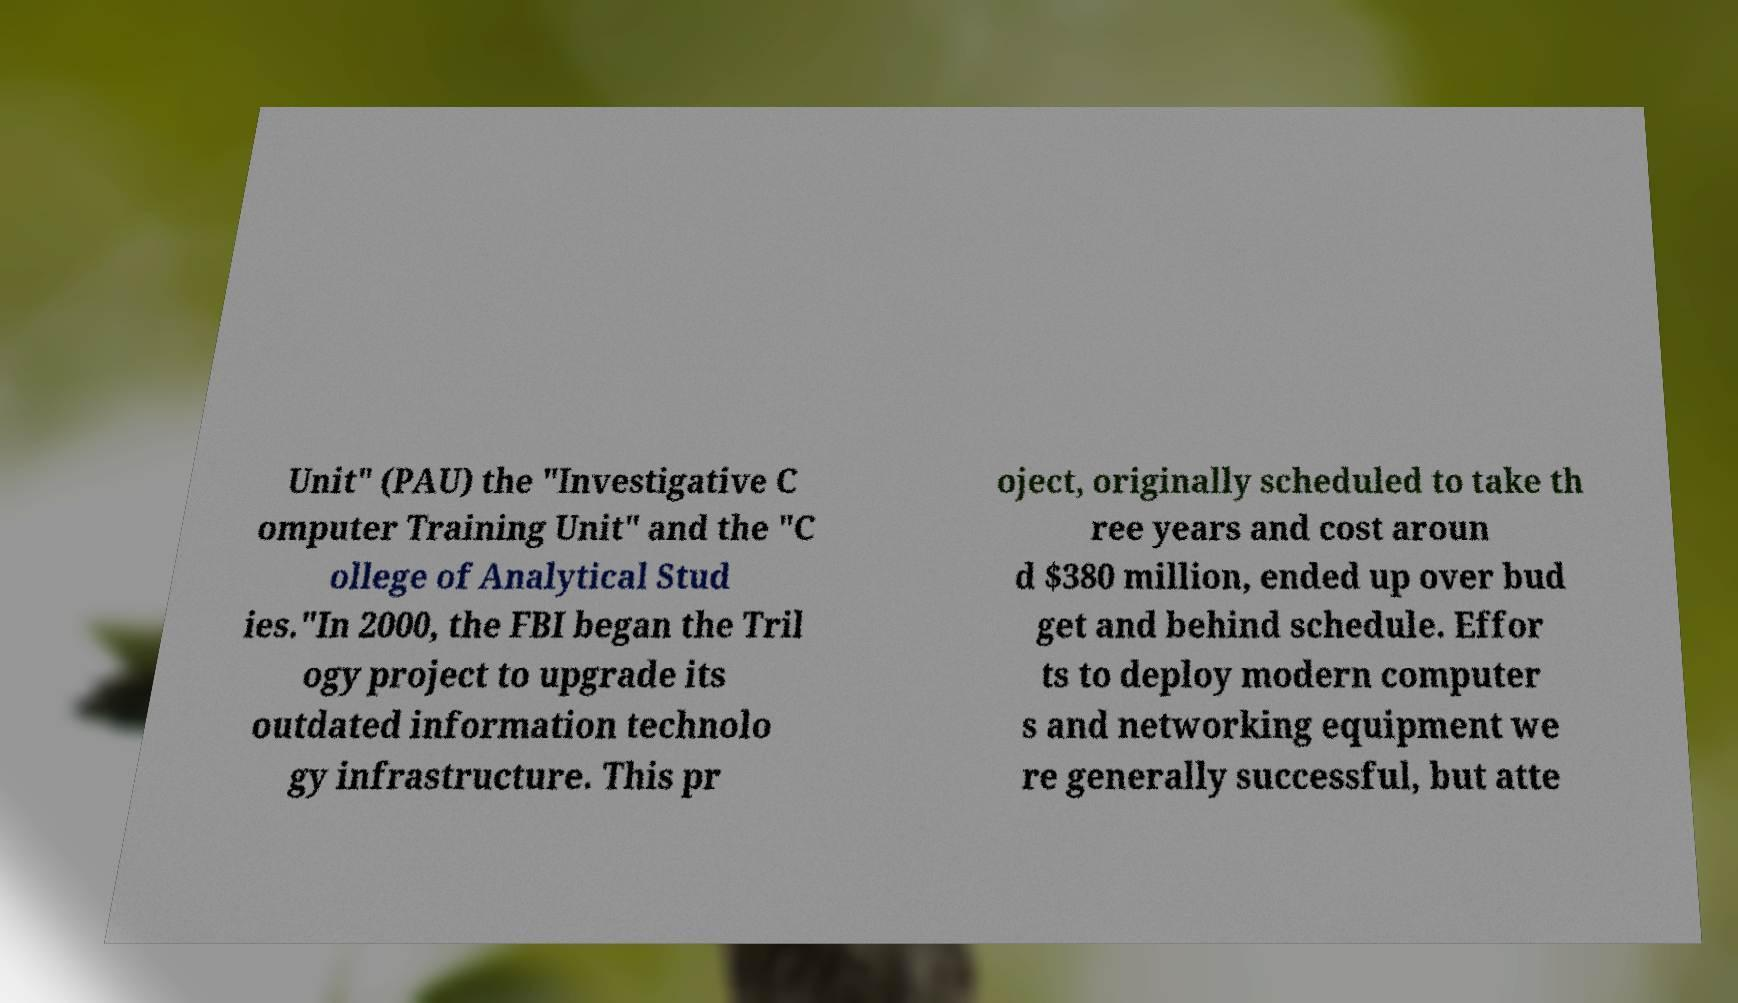Please read and relay the text visible in this image. What does it say? Unit" (PAU) the "Investigative C omputer Training Unit" and the "C ollege of Analytical Stud ies."In 2000, the FBI began the Tril ogy project to upgrade its outdated information technolo gy infrastructure. This pr oject, originally scheduled to take th ree years and cost aroun d $380 million, ended up over bud get and behind schedule. Effor ts to deploy modern computer s and networking equipment we re generally successful, but atte 